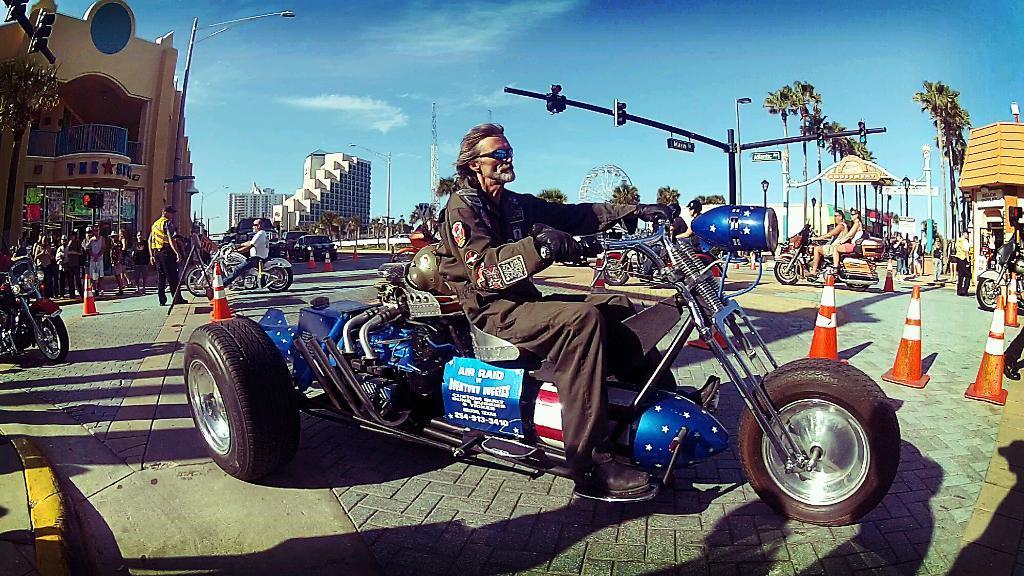How would you summarize this image in a sentence or two? In the foreground of this image, there is a man riding a bike on the road. In the background, there are few people riding bikes, traffic cones, few people walking, poles, trees, buildings, a tower, vehicles, giant wheel and the sky. 